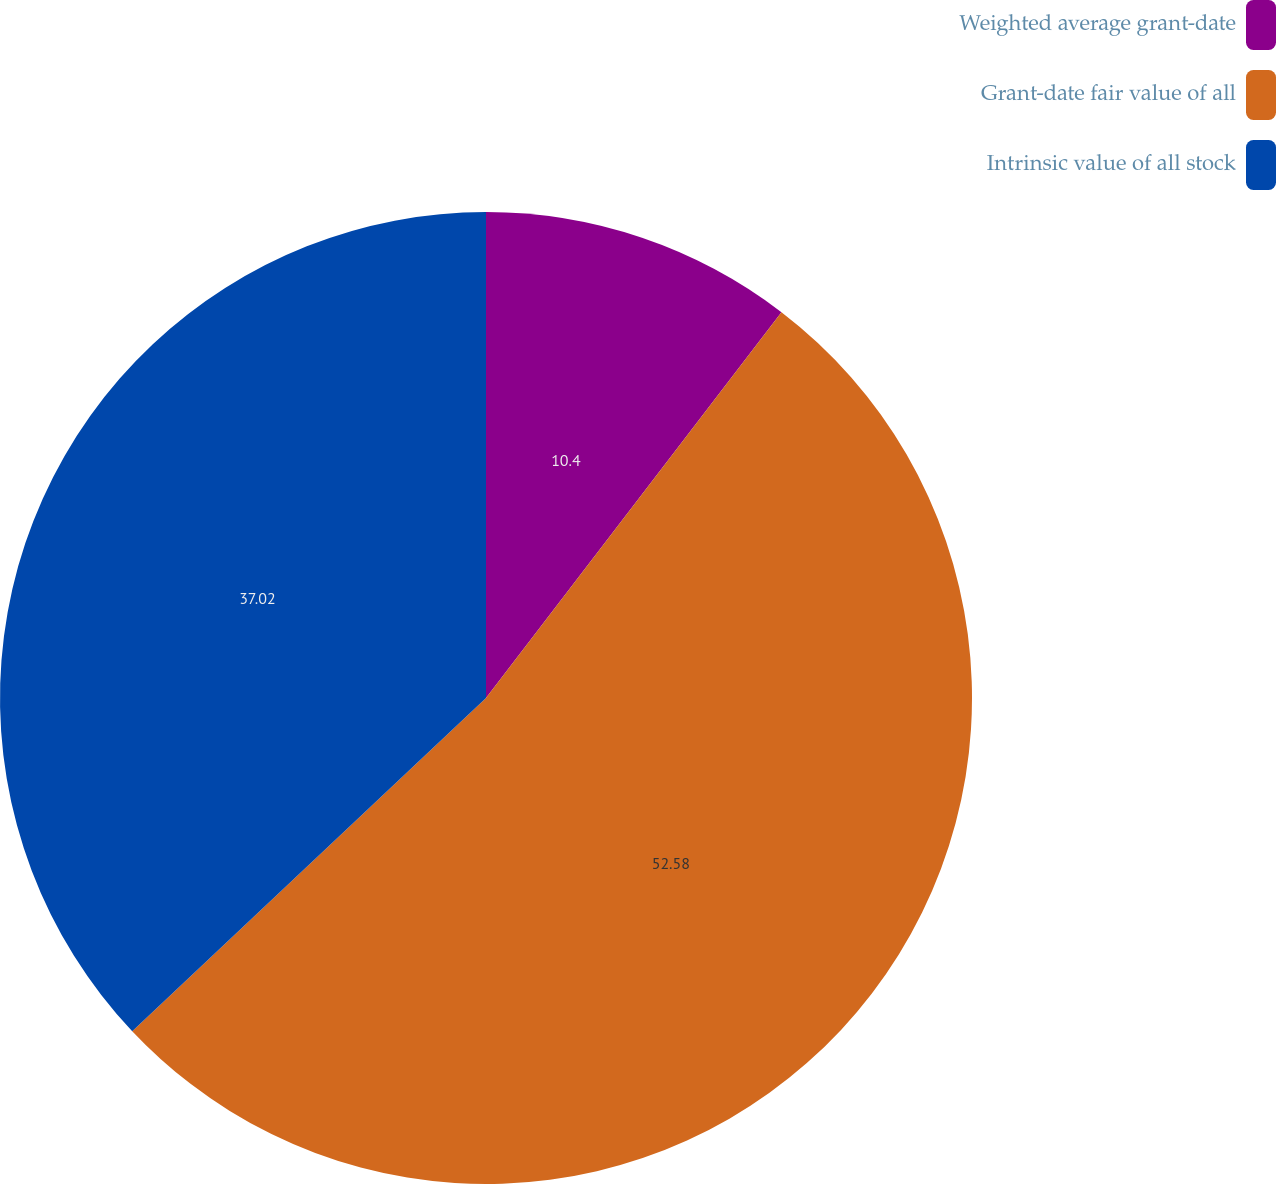<chart> <loc_0><loc_0><loc_500><loc_500><pie_chart><fcel>Weighted average grant-date<fcel>Grant-date fair value of all<fcel>Intrinsic value of all stock<nl><fcel>10.4%<fcel>52.57%<fcel>37.02%<nl></chart> 